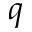<formula> <loc_0><loc_0><loc_500><loc_500>q</formula> 